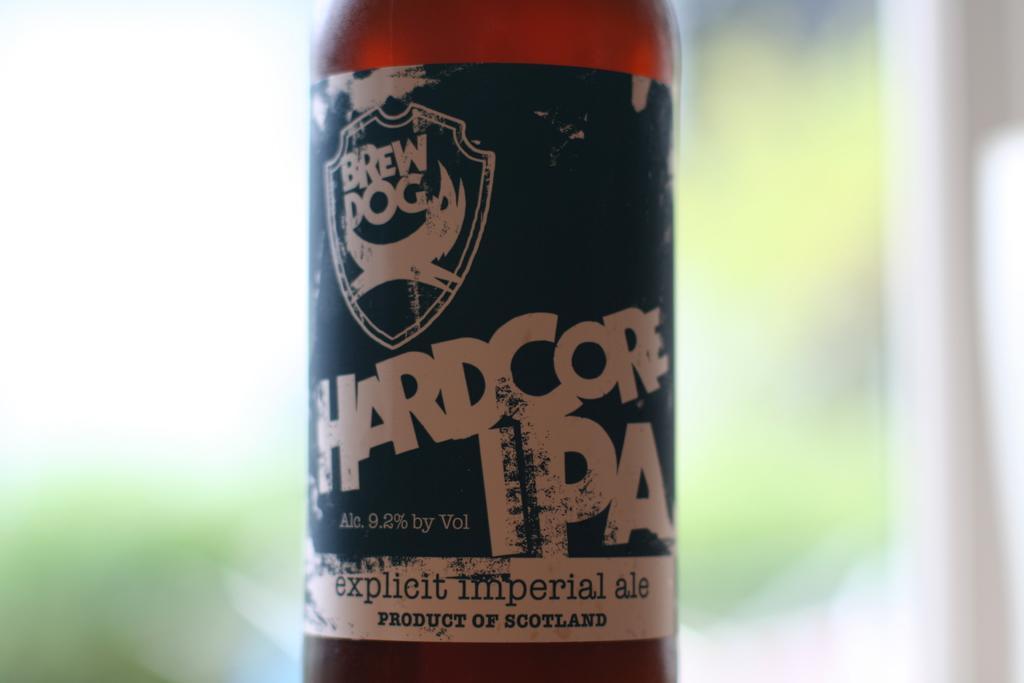Could you give a brief overview of what you see in this image? In this image there is a bottle at the middle of image. On the bottle there is label having some text on it. Background is blurry. 